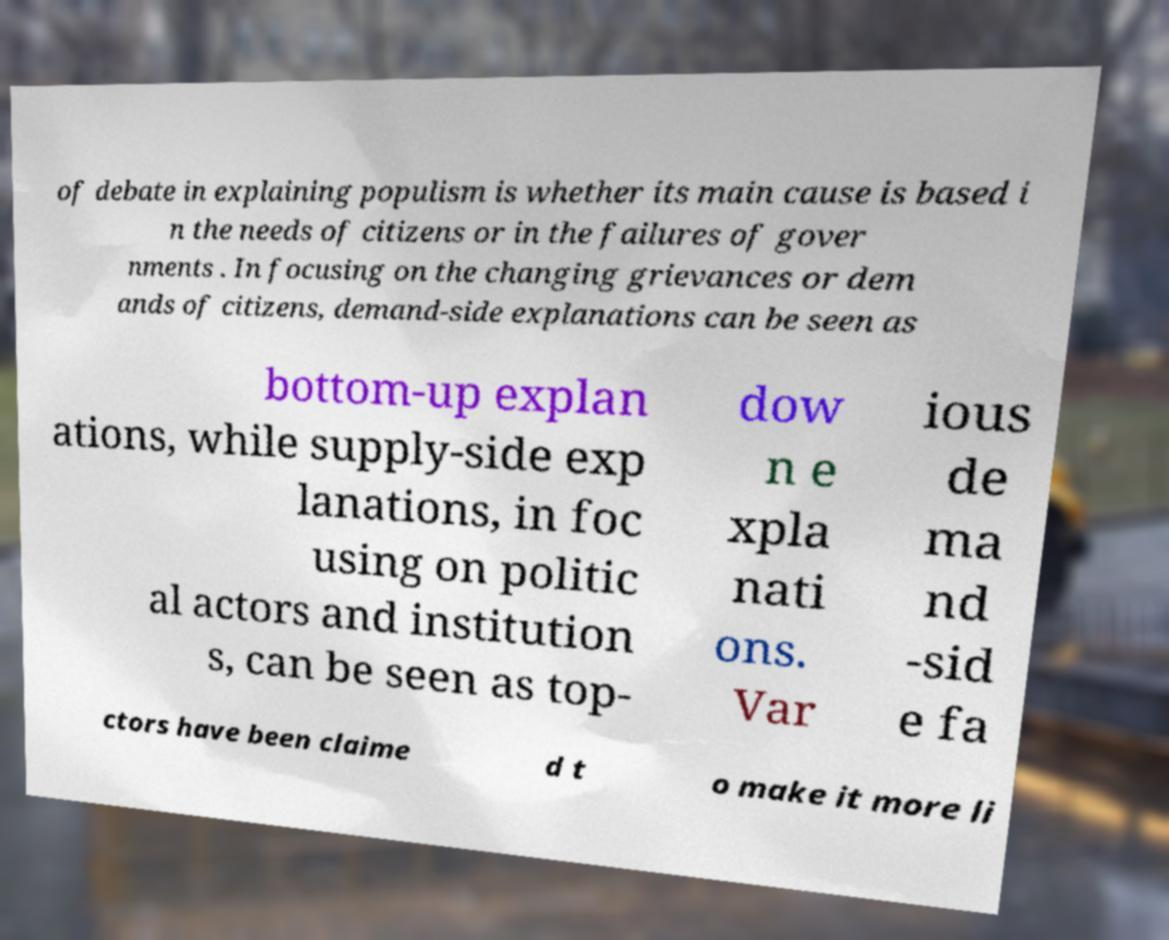Can you read and provide the text displayed in the image?This photo seems to have some interesting text. Can you extract and type it out for me? of debate in explaining populism is whether its main cause is based i n the needs of citizens or in the failures of gover nments . In focusing on the changing grievances or dem ands of citizens, demand-side explanations can be seen as bottom-up explan ations, while supply-side exp lanations, in foc using on politic al actors and institution s, can be seen as top- dow n e xpla nati ons. Var ious de ma nd -sid e fa ctors have been claime d t o make it more li 